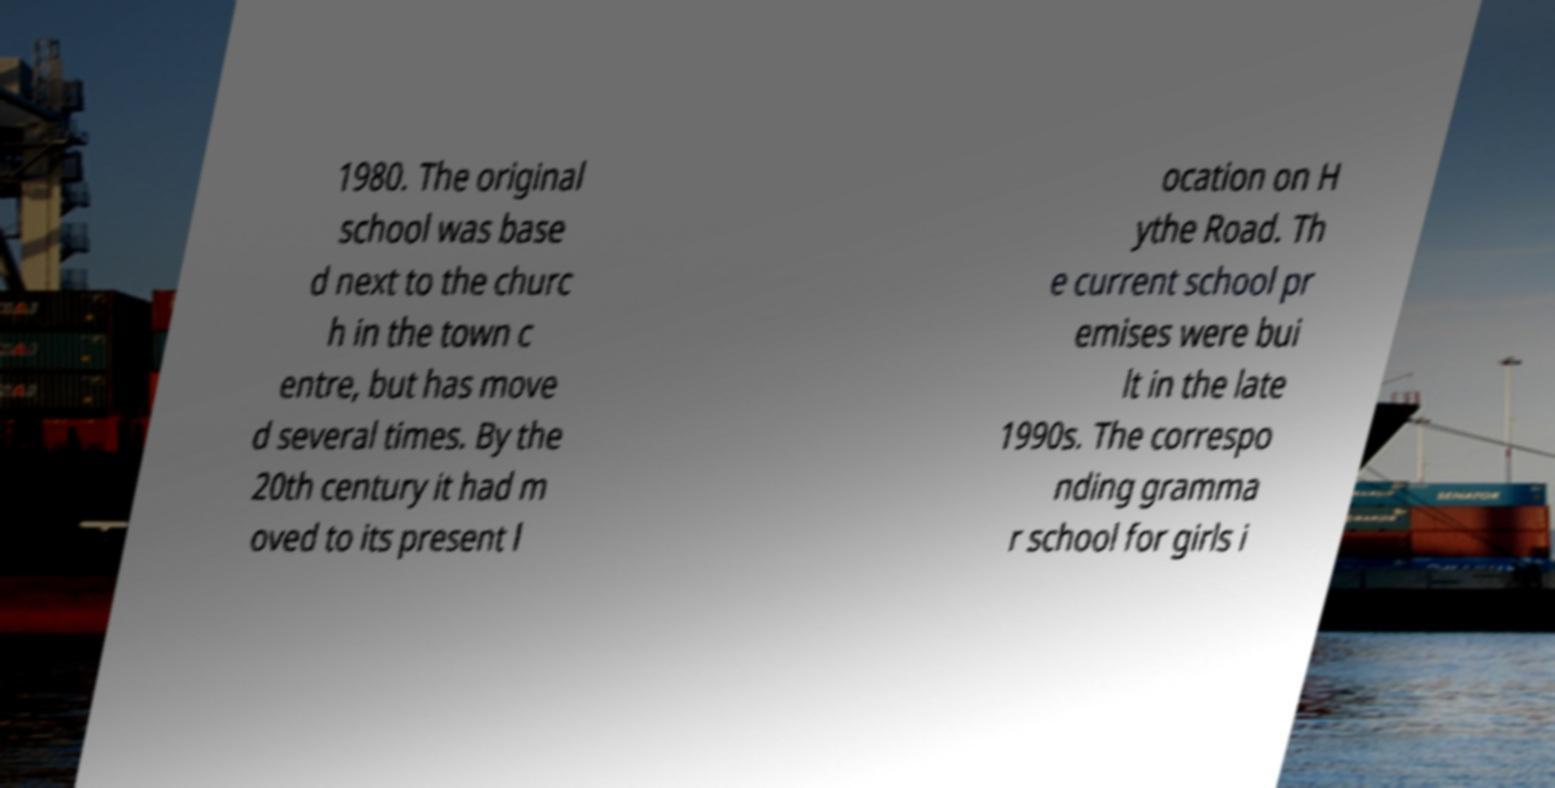Please read and relay the text visible in this image. What does it say? 1980. The original school was base d next to the churc h in the town c entre, but has move d several times. By the 20th century it had m oved to its present l ocation on H ythe Road. Th e current school pr emises were bui lt in the late 1990s. The correspo nding gramma r school for girls i 